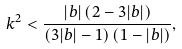Convert formula to latex. <formula><loc_0><loc_0><loc_500><loc_500>k ^ { 2 } < \frac { | b | \left ( 2 - 3 | b | \right ) } { \left ( 3 | b | - 1 \right ) \left ( 1 - | b | \right ) } ,</formula> 